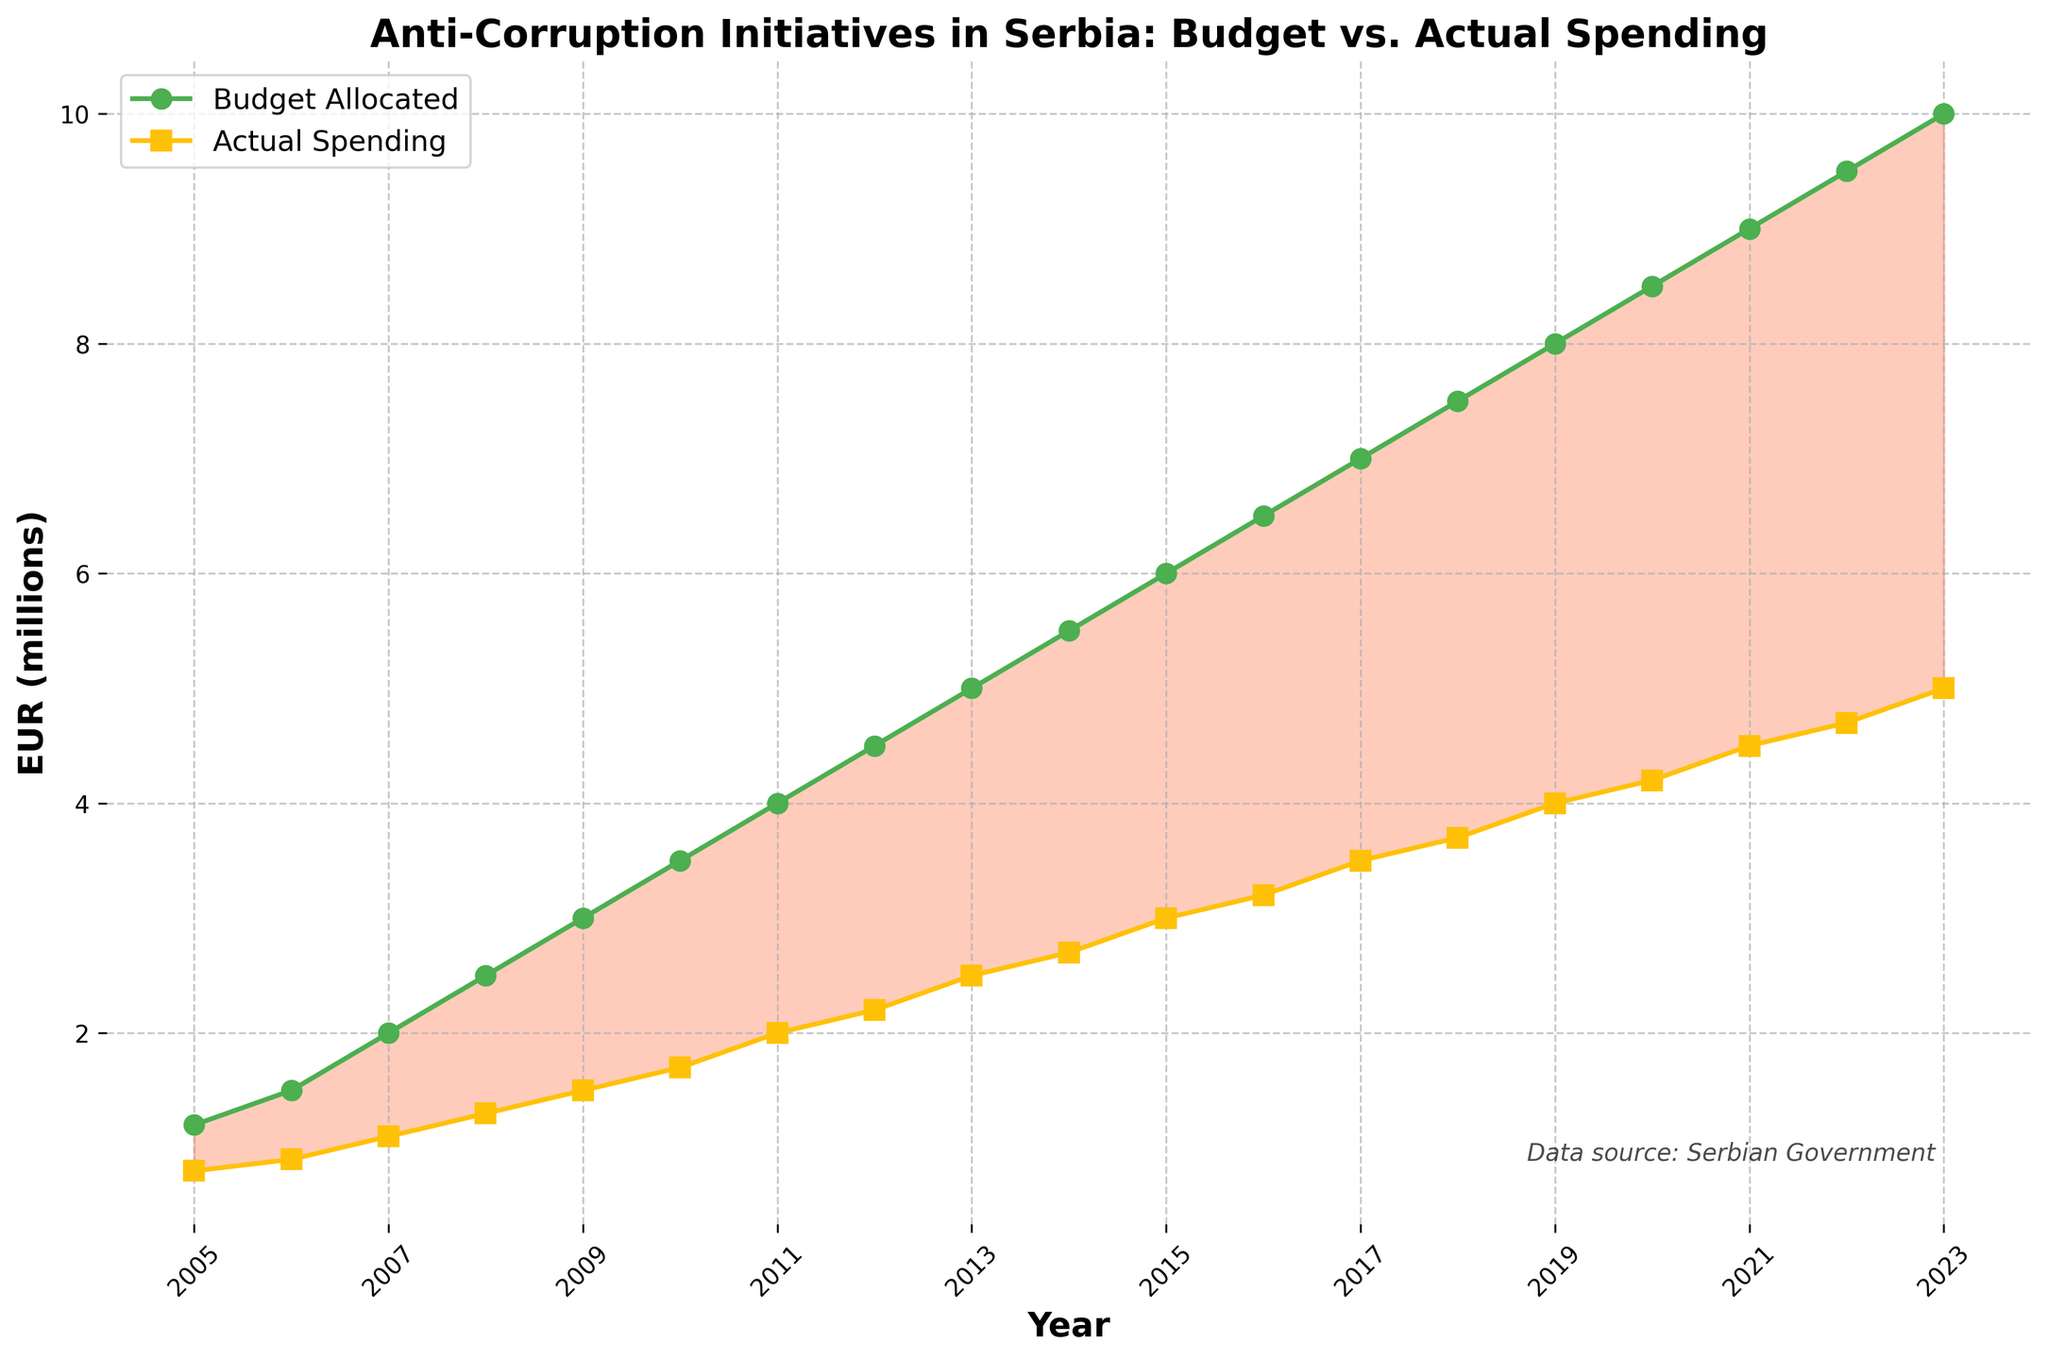What is the difference between the budget allocated and the actual spending for anti-corruption initiatives in 2010? The budget allocated for 2010 is 3.5 million EUR and the actual spending is 1.7 million EUR. The difference is calculated as 3.5 - 1.7 = 1.8 million EUR.
Answer: 1.8 million EUR In which year was the gap between the budget allocated and actual spending the largest? The largest gap is observed when the difference between the budget allocated and the actual spending is the highest. This occurs in 2023 where the budget allocated was 10.0 million EUR and the actual spending was 5.0 million EUR. The difference is 5.0 million EUR.
Answer: 2023 Compare the growth rates of budget allocated from 2005 to 2010 and actual spending in the same period. Which grew faster? Growth rate of budget allocated from 2005 (1.2) to 2010 (3.5) is calculated as (3.5 - 1.2)/1.2 * 100 = 191.67%. Growth rate of actual spending from 2005 (0.8) to 2010 (1.7) is (1.7 - 0.8)/0.8 * 100 = 112.5%. The budget allocated grew faster.
Answer: Budget allocated What is the trend in the difference between the budget allocated and actual spending over the period 2005 to 2023? By examining the visual difference (the shaded area between the two lines), the difference grew larger over the years, indicating an increasing gap between the budget allocated and the actual spending.
Answer: Increasing gap In which years did the actual spending exceed half of the budget allocated? For actual spending to exceed half of the budget allocated, Actual Spending should be greater than Budget Allocated / 2. This occurs from 2018 to 2023.
Answer: 2018-2023 Calculate the average actual spending over the entire period. Sum of all actual spendings (0.8+0.9+1.1+1.3+1.5+1.7+2.0+2.2+2.5+2.7+3.0+3.2+3.5+3.7+4.0+4.2+4.5+4.7+5.0) = 58.6. There are 19 years, so the average = 58.6 / 19 = 3.08 million EUR.
Answer: 3.08 million EUR Which year had the smallest difference between the budget allocated and actual spending? The smallest difference can be seen in 2005 where budget allocated was 1.2 million EUR and actual spending was 0.8 million EUR. The difference is 0.4 million EUR.
Answer: 2005 In 2023, what percentage of the allocated budget was actually spent? The actual spending in 2023 was 5.0 million EUR out of the allocated 10.0 million EUR. This can be calculated as (5.0 / 10.0) * 100 = 50%.
Answer: 50% How many years saw actual spending less than 40% of the budget allocated? Calculate 40% of the budget allocated for each year, then compare it with the actual spending. The years are 2005, 2006, 2007, 2008, 2009, 2010 where the actual spending was consistently less than 40% of the budget allocated.
Answer: 6 years Which year had the highest actual spending but the lowest relative percentage based on its allocated budget? The highest actual spending was in 2023 with 5.0 million EUR, but the relative percentage based on the allocated budget (50%) was the lowest in that year.
Answer: 2023 